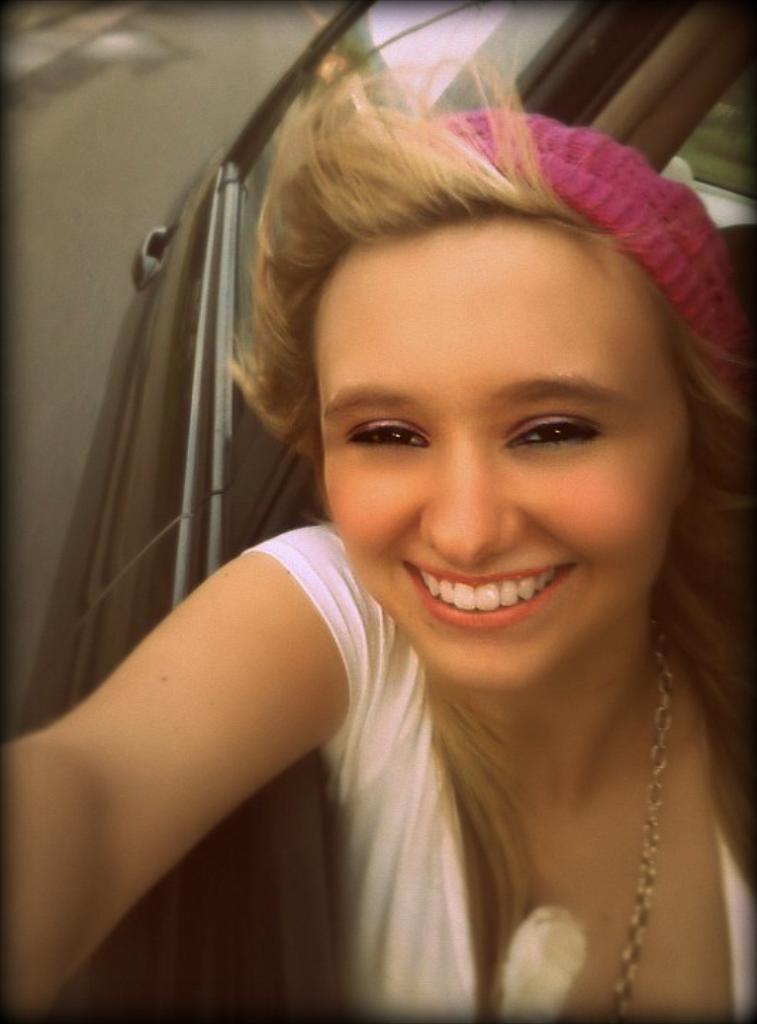In one or two sentences, can you explain what this image depicts? In the picture we can see a car which is black in color and in the car we can see a woman sitting and looking outside of the car and she is smiling and she is with a white dress and to her hair we can see a pink color band and in the background we can see a road. 